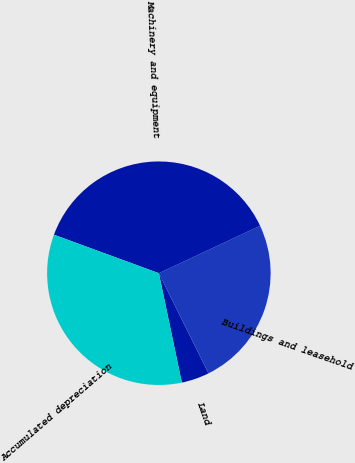<chart> <loc_0><loc_0><loc_500><loc_500><pie_chart><fcel>Land<fcel>Buildings and leasehold<fcel>Machinery and equipment<fcel>Accumulated depreciation<nl><fcel>4.03%<fcel>24.65%<fcel>37.43%<fcel>33.89%<nl></chart> 